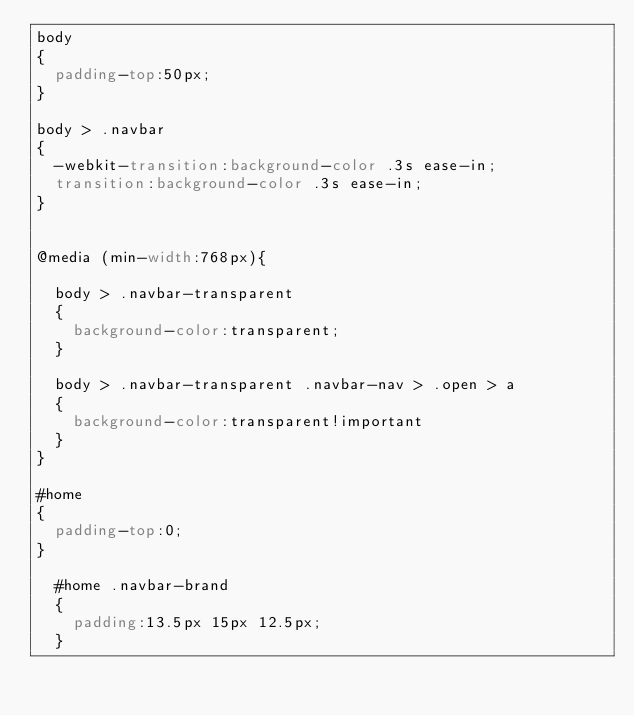<code> <loc_0><loc_0><loc_500><loc_500><_CSS_>body
{
	padding-top:50px;
}

body > .navbar
{
	-webkit-transition:background-color .3s ease-in;
	transition:background-color .3s ease-in;
}


@media (min-width:768px){

	body > .navbar-transparent
	{
		background-color:transparent;
	}

	body > .navbar-transparent .navbar-nav > .open > a
	{
		background-color:transparent!important
	}
}

#home
{
	padding-top:0;
}

	#home .navbar-brand
	{
		padding:13.5px 15px 12.5px;
	}
</code> 